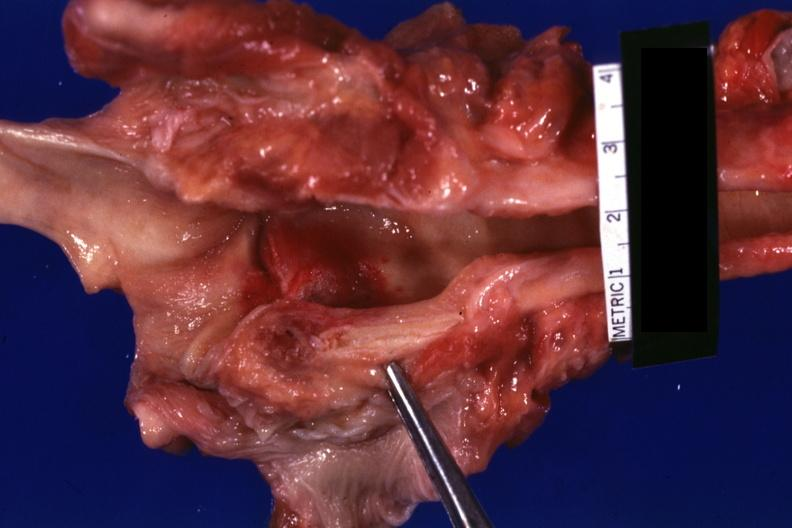where is this?
Answer the question using a single word or phrase. Oral 